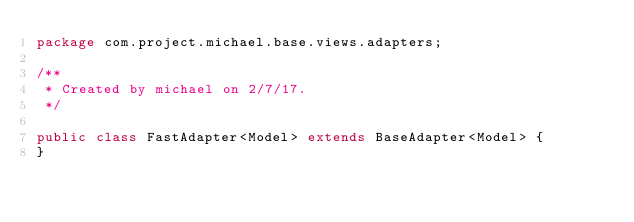Convert code to text. <code><loc_0><loc_0><loc_500><loc_500><_Java_>package com.project.michael.base.views.adapters;

/**
 * Created by michael on 2/7/17.
 */

public class FastAdapter<Model> extends BaseAdapter<Model> {
}
</code> 